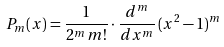Convert formula to latex. <formula><loc_0><loc_0><loc_500><loc_500>P _ { m } ( x ) = \frac { 1 } { 2 ^ { m } \, m ! } \cdot \frac { d ^ { m } } { d x ^ { m } } \, ( x ^ { 2 } - 1 ) ^ { m }</formula> 